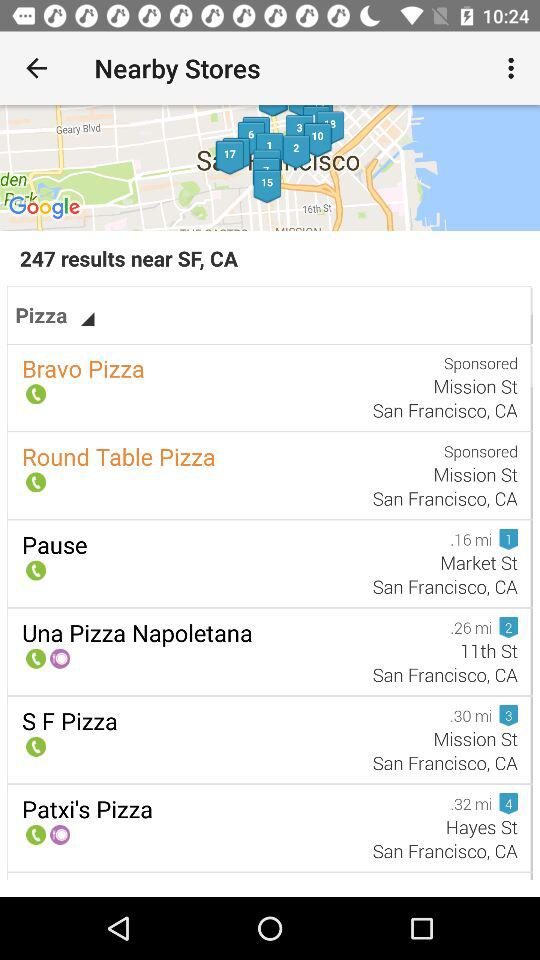What is the location of "Bravo Pizza"? The location of "Bravo Pizza" is Mission St., San Francisco, CA. 